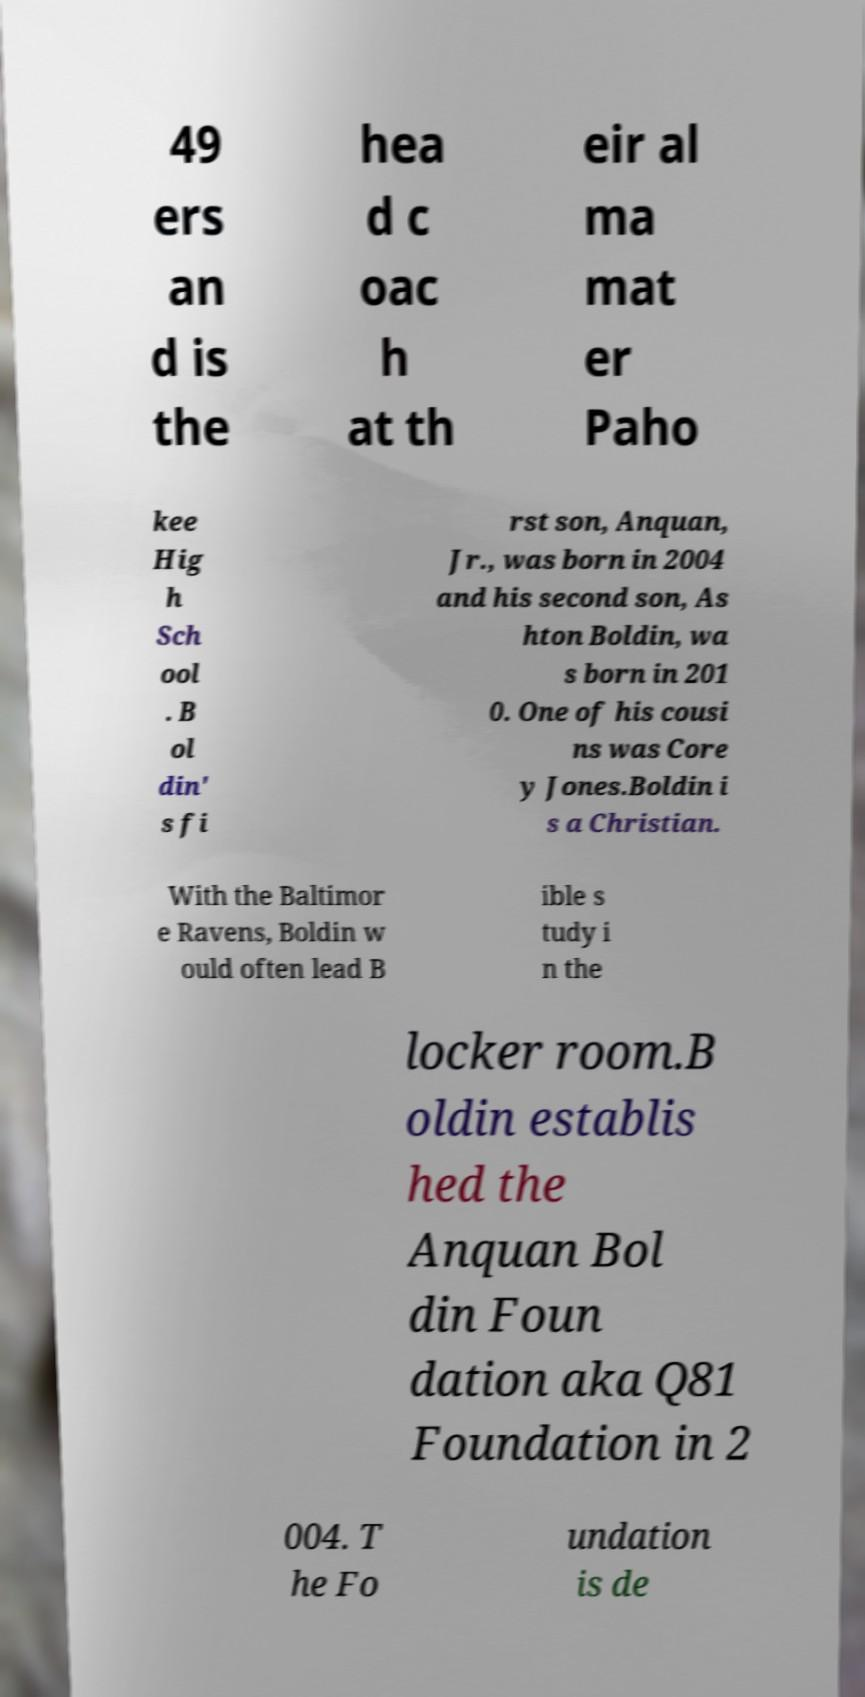I need the written content from this picture converted into text. Can you do that? 49 ers an d is the hea d c oac h at th eir al ma mat er Paho kee Hig h Sch ool . B ol din' s fi rst son, Anquan, Jr., was born in 2004 and his second son, As hton Boldin, wa s born in 201 0. One of his cousi ns was Core y Jones.Boldin i s a Christian. With the Baltimor e Ravens, Boldin w ould often lead B ible s tudy i n the locker room.B oldin establis hed the Anquan Bol din Foun dation aka Q81 Foundation in 2 004. T he Fo undation is de 